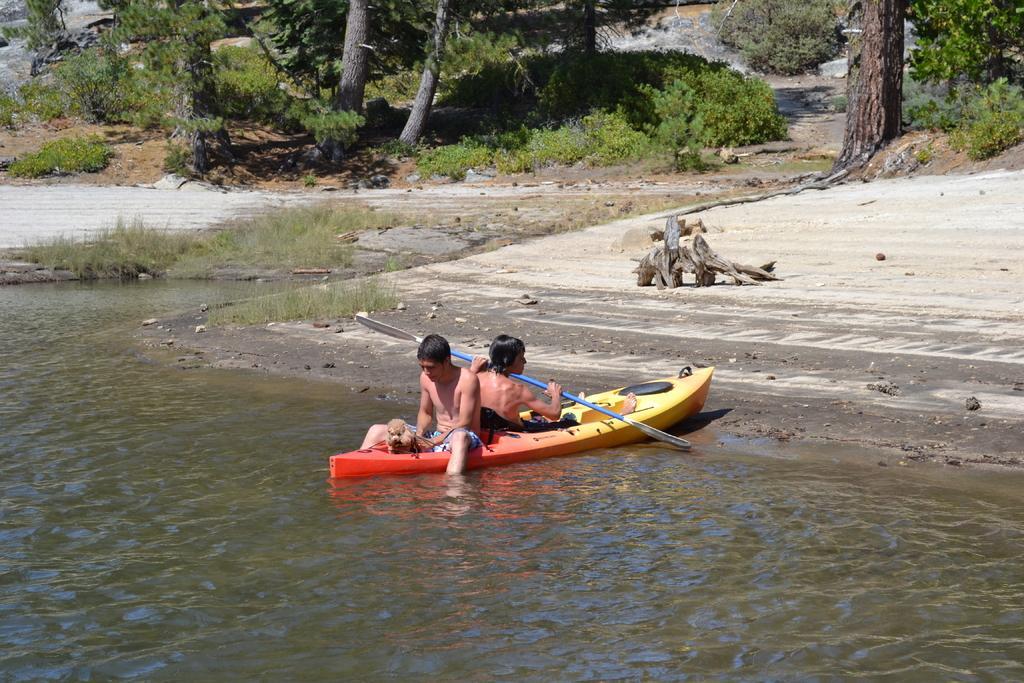Describe this image in one or two sentences. In the center of the image we can see two persons on the boat sailing on the river. In the background there are trees, plants and stones. At the bottom there is a water. 